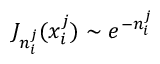<formula> <loc_0><loc_0><loc_500><loc_500>J _ { n _ { i } ^ { j } } ( x _ { i } ^ { j } ) \sim e ^ { - n _ { i } ^ { j } }</formula> 